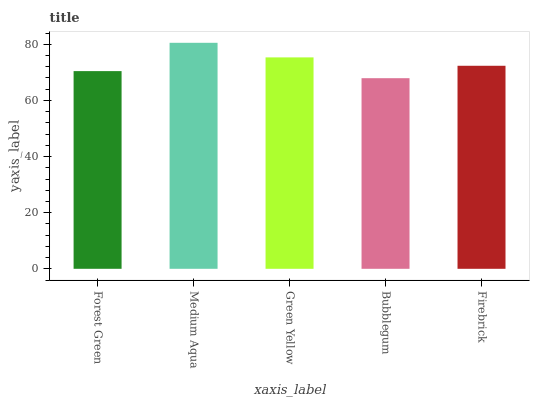Is Bubblegum the minimum?
Answer yes or no. Yes. Is Medium Aqua the maximum?
Answer yes or no. Yes. Is Green Yellow the minimum?
Answer yes or no. No. Is Green Yellow the maximum?
Answer yes or no. No. Is Medium Aqua greater than Green Yellow?
Answer yes or no. Yes. Is Green Yellow less than Medium Aqua?
Answer yes or no. Yes. Is Green Yellow greater than Medium Aqua?
Answer yes or no. No. Is Medium Aqua less than Green Yellow?
Answer yes or no. No. Is Firebrick the high median?
Answer yes or no. Yes. Is Firebrick the low median?
Answer yes or no. Yes. Is Medium Aqua the high median?
Answer yes or no. No. Is Medium Aqua the low median?
Answer yes or no. No. 